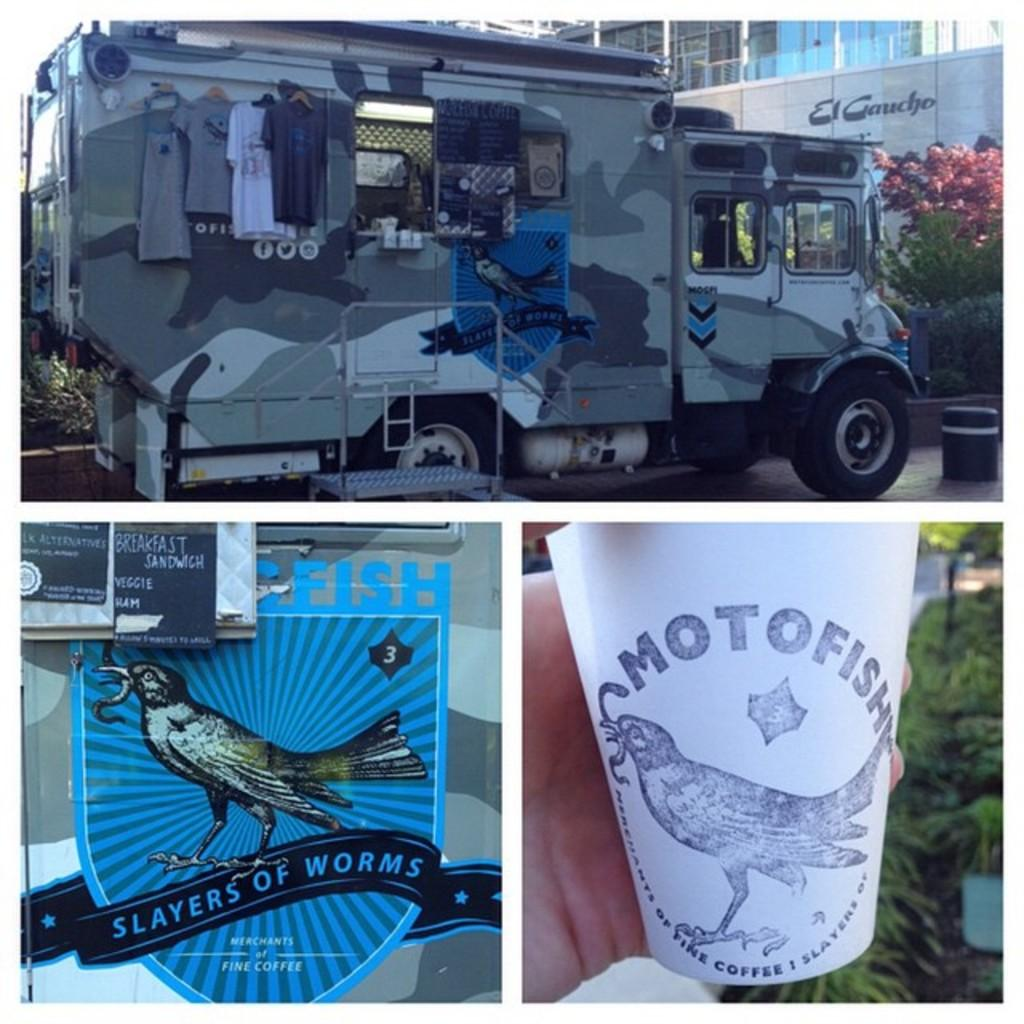<image>
Relay a brief, clear account of the picture shown. A green camoed truck have the logo for slayers of worms on its side. 